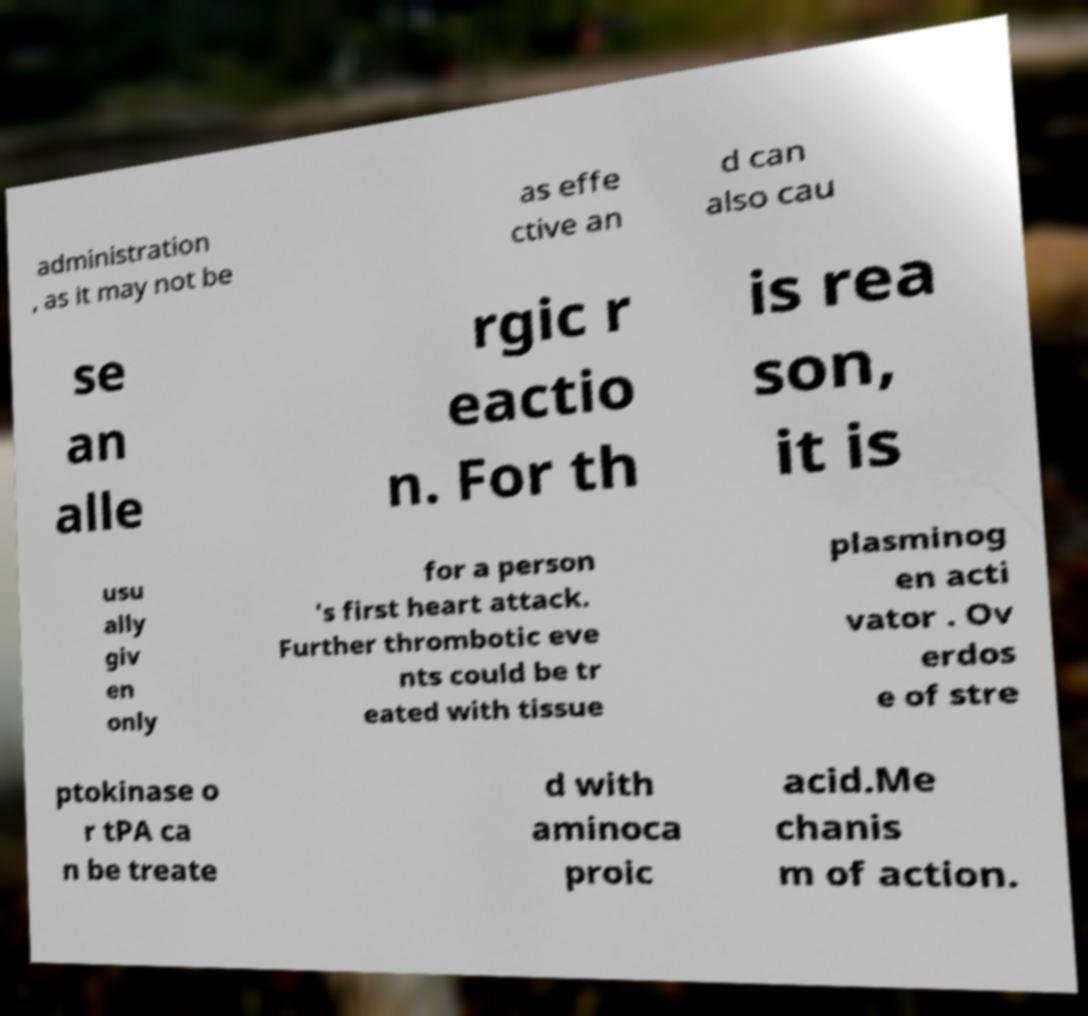Could you extract and type out the text from this image? administration , as it may not be as effe ctive an d can also cau se an alle rgic r eactio n. For th is rea son, it is usu ally giv en only for a person 's first heart attack. Further thrombotic eve nts could be tr eated with tissue plasminog en acti vator . Ov erdos e of stre ptokinase o r tPA ca n be treate d with aminoca proic acid.Me chanis m of action. 